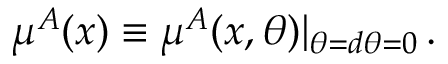<formula> <loc_0><loc_0><loc_500><loc_500>\mu ^ { A } ( x ) \equiv \mu ^ { A } ( x , \theta ) | _ { \theta = d \theta = 0 } \, .</formula> 